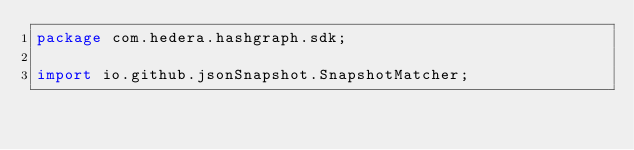Convert code to text. <code><loc_0><loc_0><loc_500><loc_500><_Java_>package com.hedera.hashgraph.sdk;

import io.github.jsonSnapshot.SnapshotMatcher;</code> 